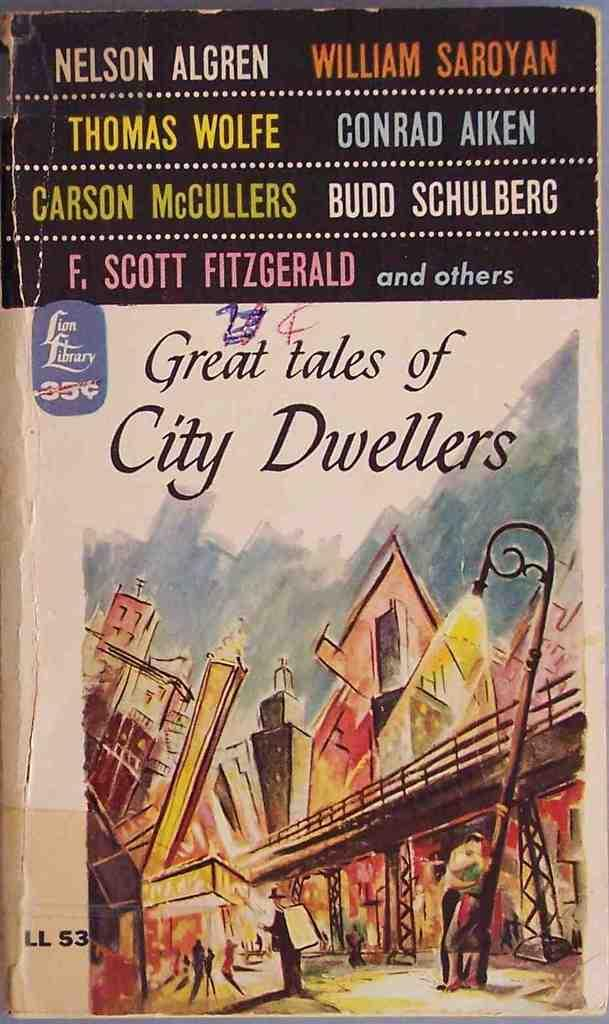Provide a one-sentence caption for the provided image. The cover of a paperback book titled Great tales of City Dwellers. 